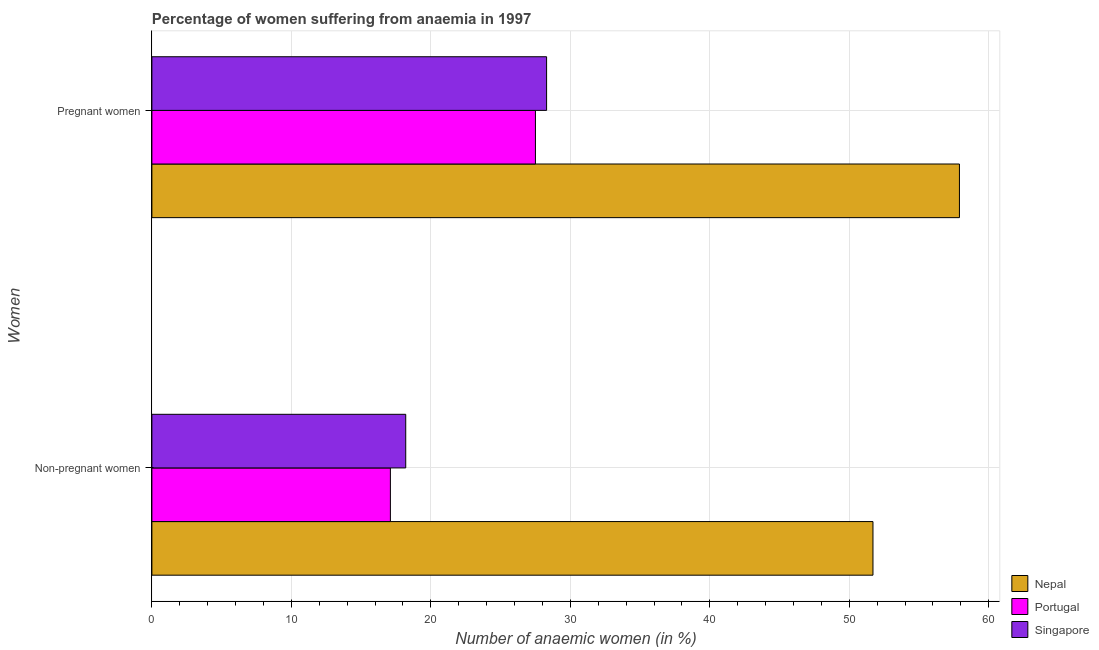How many groups of bars are there?
Your answer should be compact. 2. What is the label of the 2nd group of bars from the top?
Provide a short and direct response. Non-pregnant women. What is the percentage of pregnant anaemic women in Singapore?
Ensure brevity in your answer.  28.3. Across all countries, what is the maximum percentage of non-pregnant anaemic women?
Offer a terse response. 51.7. In which country was the percentage of non-pregnant anaemic women maximum?
Give a very brief answer. Nepal. What is the total percentage of pregnant anaemic women in the graph?
Provide a succinct answer. 113.7. What is the difference between the percentage of pregnant anaemic women in Singapore and that in Portugal?
Ensure brevity in your answer.  0.8. What is the difference between the percentage of pregnant anaemic women in Portugal and the percentage of non-pregnant anaemic women in Nepal?
Offer a very short reply. -24.2. What is the average percentage of non-pregnant anaemic women per country?
Your answer should be very brief. 29. What is the difference between the percentage of pregnant anaemic women and percentage of non-pregnant anaemic women in Singapore?
Keep it short and to the point. 10.1. What is the ratio of the percentage of pregnant anaemic women in Nepal to that in Singapore?
Provide a succinct answer. 2.05. In how many countries, is the percentage of non-pregnant anaemic women greater than the average percentage of non-pregnant anaemic women taken over all countries?
Provide a succinct answer. 1. What does the 1st bar from the top in Non-pregnant women represents?
Make the answer very short. Singapore. What does the 1st bar from the bottom in Pregnant women represents?
Your response must be concise. Nepal. Are all the bars in the graph horizontal?
Make the answer very short. Yes. What is the difference between two consecutive major ticks on the X-axis?
Your answer should be very brief. 10. Where does the legend appear in the graph?
Give a very brief answer. Bottom right. How many legend labels are there?
Give a very brief answer. 3. How are the legend labels stacked?
Provide a short and direct response. Vertical. What is the title of the graph?
Ensure brevity in your answer.  Percentage of women suffering from anaemia in 1997. Does "South Africa" appear as one of the legend labels in the graph?
Offer a very short reply. No. What is the label or title of the X-axis?
Provide a succinct answer. Number of anaemic women (in %). What is the label or title of the Y-axis?
Give a very brief answer. Women. What is the Number of anaemic women (in %) of Nepal in Non-pregnant women?
Offer a very short reply. 51.7. What is the Number of anaemic women (in %) in Portugal in Non-pregnant women?
Your response must be concise. 17.1. What is the Number of anaemic women (in %) in Singapore in Non-pregnant women?
Make the answer very short. 18.2. What is the Number of anaemic women (in %) of Nepal in Pregnant women?
Keep it short and to the point. 57.9. What is the Number of anaemic women (in %) of Singapore in Pregnant women?
Make the answer very short. 28.3. Across all Women, what is the maximum Number of anaemic women (in %) in Nepal?
Offer a terse response. 57.9. Across all Women, what is the maximum Number of anaemic women (in %) of Singapore?
Provide a succinct answer. 28.3. Across all Women, what is the minimum Number of anaemic women (in %) in Nepal?
Your response must be concise. 51.7. What is the total Number of anaemic women (in %) in Nepal in the graph?
Provide a succinct answer. 109.6. What is the total Number of anaemic women (in %) in Portugal in the graph?
Keep it short and to the point. 44.6. What is the total Number of anaemic women (in %) in Singapore in the graph?
Offer a very short reply. 46.5. What is the difference between the Number of anaemic women (in %) of Nepal in Non-pregnant women and that in Pregnant women?
Ensure brevity in your answer.  -6.2. What is the difference between the Number of anaemic women (in %) in Singapore in Non-pregnant women and that in Pregnant women?
Your answer should be very brief. -10.1. What is the difference between the Number of anaemic women (in %) of Nepal in Non-pregnant women and the Number of anaemic women (in %) of Portugal in Pregnant women?
Give a very brief answer. 24.2. What is the difference between the Number of anaemic women (in %) in Nepal in Non-pregnant women and the Number of anaemic women (in %) in Singapore in Pregnant women?
Your answer should be very brief. 23.4. What is the difference between the Number of anaemic women (in %) of Portugal in Non-pregnant women and the Number of anaemic women (in %) of Singapore in Pregnant women?
Your answer should be very brief. -11.2. What is the average Number of anaemic women (in %) in Nepal per Women?
Your response must be concise. 54.8. What is the average Number of anaemic women (in %) of Portugal per Women?
Make the answer very short. 22.3. What is the average Number of anaemic women (in %) of Singapore per Women?
Your answer should be compact. 23.25. What is the difference between the Number of anaemic women (in %) of Nepal and Number of anaemic women (in %) of Portugal in Non-pregnant women?
Keep it short and to the point. 34.6. What is the difference between the Number of anaemic women (in %) in Nepal and Number of anaemic women (in %) in Singapore in Non-pregnant women?
Your answer should be very brief. 33.5. What is the difference between the Number of anaemic women (in %) in Portugal and Number of anaemic women (in %) in Singapore in Non-pregnant women?
Offer a terse response. -1.1. What is the difference between the Number of anaemic women (in %) in Nepal and Number of anaemic women (in %) in Portugal in Pregnant women?
Provide a short and direct response. 30.4. What is the difference between the Number of anaemic women (in %) in Nepal and Number of anaemic women (in %) in Singapore in Pregnant women?
Offer a terse response. 29.6. What is the difference between the Number of anaemic women (in %) in Portugal and Number of anaemic women (in %) in Singapore in Pregnant women?
Provide a succinct answer. -0.8. What is the ratio of the Number of anaemic women (in %) in Nepal in Non-pregnant women to that in Pregnant women?
Offer a very short reply. 0.89. What is the ratio of the Number of anaemic women (in %) in Portugal in Non-pregnant women to that in Pregnant women?
Give a very brief answer. 0.62. What is the ratio of the Number of anaemic women (in %) of Singapore in Non-pregnant women to that in Pregnant women?
Ensure brevity in your answer.  0.64. What is the difference between the highest and the second highest Number of anaemic women (in %) in Portugal?
Your answer should be very brief. 10.4. What is the difference between the highest and the second highest Number of anaemic women (in %) in Singapore?
Your answer should be very brief. 10.1. What is the difference between the highest and the lowest Number of anaemic women (in %) in Singapore?
Your answer should be compact. 10.1. 